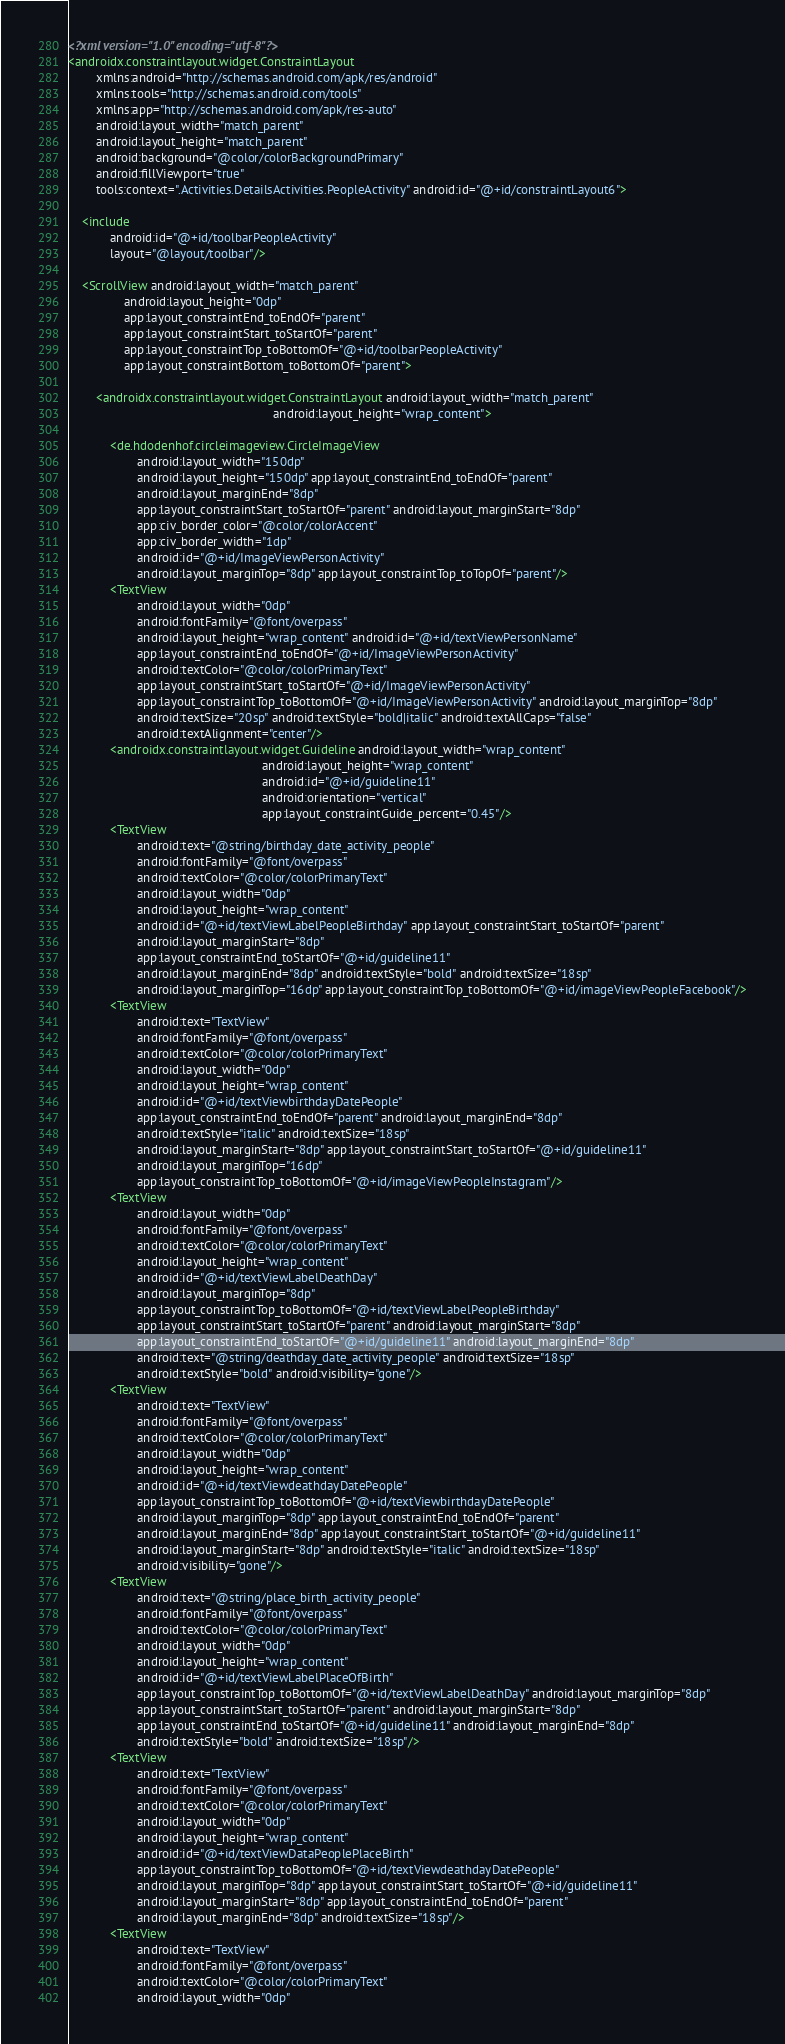<code> <loc_0><loc_0><loc_500><loc_500><_XML_><?xml version="1.0" encoding="utf-8"?>
<androidx.constraintlayout.widget.ConstraintLayout
        xmlns:android="http://schemas.android.com/apk/res/android"
        xmlns:tools="http://schemas.android.com/tools"
        xmlns:app="http://schemas.android.com/apk/res-auto"
        android:layout_width="match_parent"
        android:layout_height="match_parent"
        android:background="@color/colorBackgroundPrimary"
        android:fillViewport="true"
        tools:context=".Activities.DetailsActivities.PeopleActivity" android:id="@+id/constraintLayout6">

    <include
            android:id="@+id/toolbarPeopleActivity"
            layout="@layout/toolbar"/>

    <ScrollView android:layout_width="match_parent"
                android:layout_height="0dp"
                app:layout_constraintEnd_toEndOf="parent"
                app:layout_constraintStart_toStartOf="parent"
                app:layout_constraintTop_toBottomOf="@+id/toolbarPeopleActivity"
                app:layout_constraintBottom_toBottomOf="parent">

        <androidx.constraintlayout.widget.ConstraintLayout android:layout_width="match_parent"
                                                           android:layout_height="wrap_content">

            <de.hdodenhof.circleimageview.CircleImageView
                    android:layout_width="150dp"
                    android:layout_height="150dp" app:layout_constraintEnd_toEndOf="parent"
                    android:layout_marginEnd="8dp"
                    app:layout_constraintStart_toStartOf="parent" android:layout_marginStart="8dp"
                    app:civ_border_color="@color/colorAccent"
                    app:civ_border_width="1dp"
                    android:id="@+id/ImageViewPersonActivity"
                    android:layout_marginTop="8dp" app:layout_constraintTop_toTopOf="parent"/>
            <TextView
                    android:layout_width="0dp"
                    android:fontFamily="@font/overpass"
                    android:layout_height="wrap_content" android:id="@+id/textViewPersonName"
                    app:layout_constraintEnd_toEndOf="@+id/ImageViewPersonActivity"
                    android:textColor="@color/colorPrimaryText"
                    app:layout_constraintStart_toStartOf="@+id/ImageViewPersonActivity"
                    app:layout_constraintTop_toBottomOf="@+id/ImageViewPersonActivity" android:layout_marginTop="8dp"
                    android:textSize="20sp" android:textStyle="bold|italic" android:textAllCaps="false"
                    android:textAlignment="center"/>
            <androidx.constraintlayout.widget.Guideline android:layout_width="wrap_content"
                                                        android:layout_height="wrap_content"
                                                        android:id="@+id/guideline11"
                                                        android:orientation="vertical"
                                                        app:layout_constraintGuide_percent="0.45"/>
            <TextView
                    android:text="@string/birthday_date_activity_people"
                    android:fontFamily="@font/overpass"
                    android:textColor="@color/colorPrimaryText"
                    android:layout_width="0dp"
                    android:layout_height="wrap_content"
                    android:id="@+id/textViewLabelPeopleBirthday" app:layout_constraintStart_toStartOf="parent"
                    android:layout_marginStart="8dp"
                    app:layout_constraintEnd_toStartOf="@+id/guideline11"
                    android:layout_marginEnd="8dp" android:textStyle="bold" android:textSize="18sp"
                    android:layout_marginTop="16dp" app:layout_constraintTop_toBottomOf="@+id/imageViewPeopleFacebook"/>
            <TextView
                    android:text="TextView"
                    android:fontFamily="@font/overpass"
                    android:textColor="@color/colorPrimaryText"
                    android:layout_width="0dp"
                    android:layout_height="wrap_content"
                    android:id="@+id/textViewbirthdayDatePeople"
                    app:layout_constraintEnd_toEndOf="parent" android:layout_marginEnd="8dp"
                    android:textStyle="italic" android:textSize="18sp"
                    android:layout_marginStart="8dp" app:layout_constraintStart_toStartOf="@+id/guideline11"
                    android:layout_marginTop="16dp"
                    app:layout_constraintTop_toBottomOf="@+id/imageViewPeopleInstagram"/>
            <TextView
                    android:layout_width="0dp"
                    android:fontFamily="@font/overpass"
                    android:textColor="@color/colorPrimaryText"
                    android:layout_height="wrap_content"
                    android:id="@+id/textViewLabelDeathDay"
                    android:layout_marginTop="8dp"
                    app:layout_constraintTop_toBottomOf="@+id/textViewLabelPeopleBirthday"
                    app:layout_constraintStart_toStartOf="parent" android:layout_marginStart="8dp"
                    app:layout_constraintEnd_toStartOf="@+id/guideline11" android:layout_marginEnd="8dp"
                    android:text="@string/deathday_date_activity_people" android:textSize="18sp"
                    android:textStyle="bold" android:visibility="gone"/>
            <TextView
                    android:text="TextView"
                    android:fontFamily="@font/overpass"
                    android:textColor="@color/colorPrimaryText"
                    android:layout_width="0dp"
                    android:layout_height="wrap_content"
                    android:id="@+id/textViewdeathdayDatePeople"
                    app:layout_constraintTop_toBottomOf="@+id/textViewbirthdayDatePeople"
                    android:layout_marginTop="8dp" app:layout_constraintEnd_toEndOf="parent"
                    android:layout_marginEnd="8dp" app:layout_constraintStart_toStartOf="@+id/guideline11"
                    android:layout_marginStart="8dp" android:textStyle="italic" android:textSize="18sp"
                    android:visibility="gone"/>
            <TextView
                    android:text="@string/place_birth_activity_people"
                    android:fontFamily="@font/overpass"
                    android:textColor="@color/colorPrimaryText"
                    android:layout_width="0dp"
                    android:layout_height="wrap_content"
                    android:id="@+id/textViewLabelPlaceOfBirth"
                    app:layout_constraintTop_toBottomOf="@+id/textViewLabelDeathDay" android:layout_marginTop="8dp"
                    app:layout_constraintStart_toStartOf="parent" android:layout_marginStart="8dp"
                    app:layout_constraintEnd_toStartOf="@+id/guideline11" android:layout_marginEnd="8dp"
                    android:textStyle="bold" android:textSize="18sp"/>
            <TextView
                    android:text="TextView"
                    android:fontFamily="@font/overpass"
                    android:textColor="@color/colorPrimaryText"
                    android:layout_width="0dp"
                    android:layout_height="wrap_content"
                    android:id="@+id/textViewDataPeoplePlaceBirth"
                    app:layout_constraintTop_toBottomOf="@+id/textViewdeathdayDatePeople"
                    android:layout_marginTop="8dp" app:layout_constraintStart_toStartOf="@+id/guideline11"
                    android:layout_marginStart="8dp" app:layout_constraintEnd_toEndOf="parent"
                    android:layout_marginEnd="8dp" android:textSize="18sp"/>
            <TextView
                    android:text="TextView"
                    android:fontFamily="@font/overpass"
                    android:textColor="@color/colorPrimaryText"
                    android:layout_width="0dp"</code> 